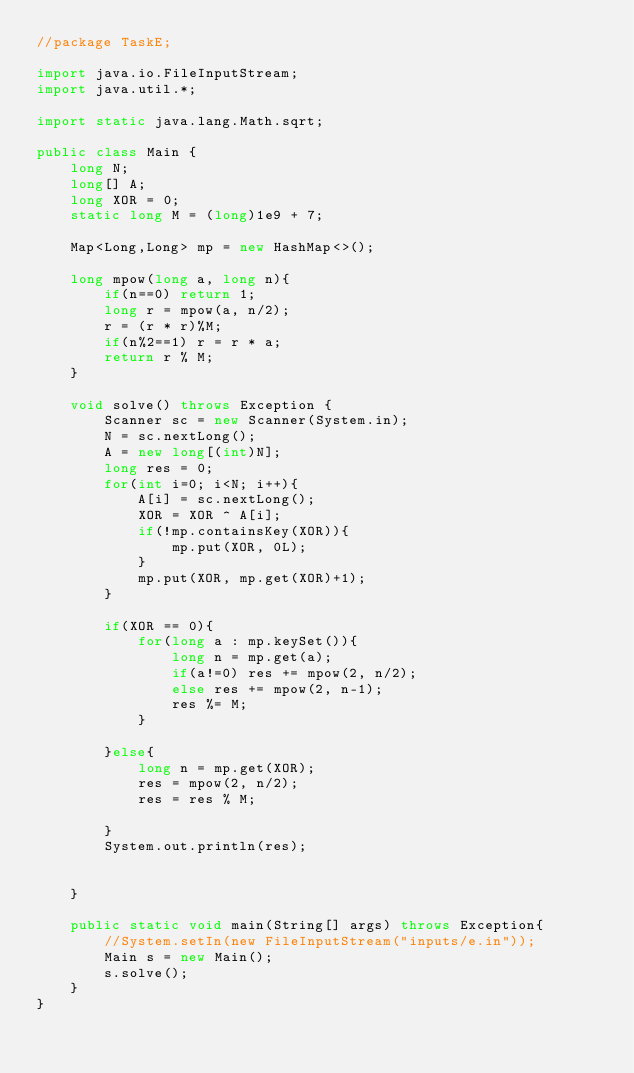<code> <loc_0><loc_0><loc_500><loc_500><_Java_>//package TaskE;

import java.io.FileInputStream;
import java.util.*;

import static java.lang.Math.sqrt;

public class Main {
    long N;
    long[] A;
    long XOR = 0;
    static long M = (long)1e9 + 7;

    Map<Long,Long> mp = new HashMap<>();

    long mpow(long a, long n){
        if(n==0) return 1;
        long r = mpow(a, n/2);
        r = (r * r)%M;
        if(n%2==1) r = r * a;
        return r % M;
    }

    void solve() throws Exception {
        Scanner sc = new Scanner(System.in);
        N = sc.nextLong();
        A = new long[(int)N];
        long res = 0;
        for(int i=0; i<N; i++){
            A[i] = sc.nextLong();
            XOR = XOR ^ A[i];
            if(!mp.containsKey(XOR)){
                mp.put(XOR, 0L);
            }
            mp.put(XOR, mp.get(XOR)+1);
        }

        if(XOR == 0){
            for(long a : mp.keySet()){
                long n = mp.get(a);
                if(a!=0) res += mpow(2, n/2);
                else res += mpow(2, n-1);
                res %= M;
            }

        }else{
            long n = mp.get(XOR);
            res = mpow(2, n/2);
            res = res % M;

        }
        System.out.println(res);


    }

    public static void main(String[] args) throws Exception{
        //System.setIn(new FileInputStream("inputs/e.in"));
        Main s = new Main();
        s.solve();
    }
}
</code> 